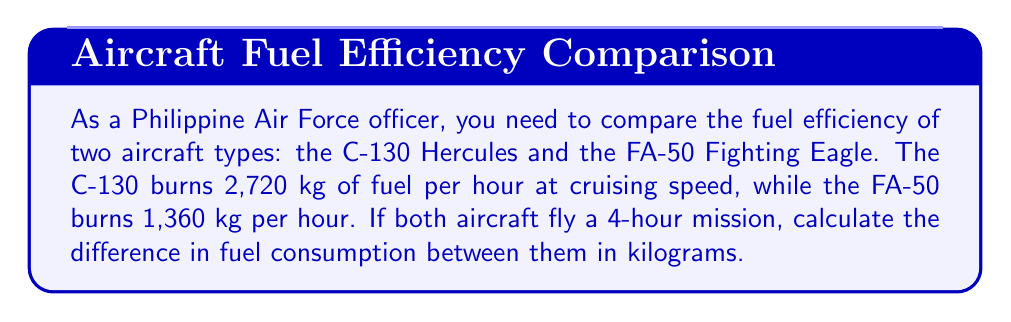Show me your answer to this math problem. Let's approach this problem step-by-step:

1. Calculate the fuel consumption for the C-130 Hercules:
   $$\text{C-130 fuel consumption} = 2,720 \frac{\text{kg}}{\text{hour}} \times 4 \text{ hours} = 10,880 \text{ kg}$$

2. Calculate the fuel consumption for the FA-50 Fighting Eagle:
   $$\text{FA-50 fuel consumption} = 1,360 \frac{\text{kg}}{\text{hour}} \times 4 \text{ hours} = 5,440 \text{ kg}$$

3. Calculate the difference in fuel consumption:
   $$\text{Difference} = \text{C-130 fuel consumption} - \text{FA-50 fuel consumption}$$
   $$\text{Difference} = 10,880 \text{ kg} - 5,440 \text{ kg} = 5,440 \text{ kg}$$

Therefore, the difference in fuel consumption between the C-130 Hercules and the FA-50 Fighting Eagle for a 4-hour mission is 5,440 kg.
Answer: 5,440 kg 